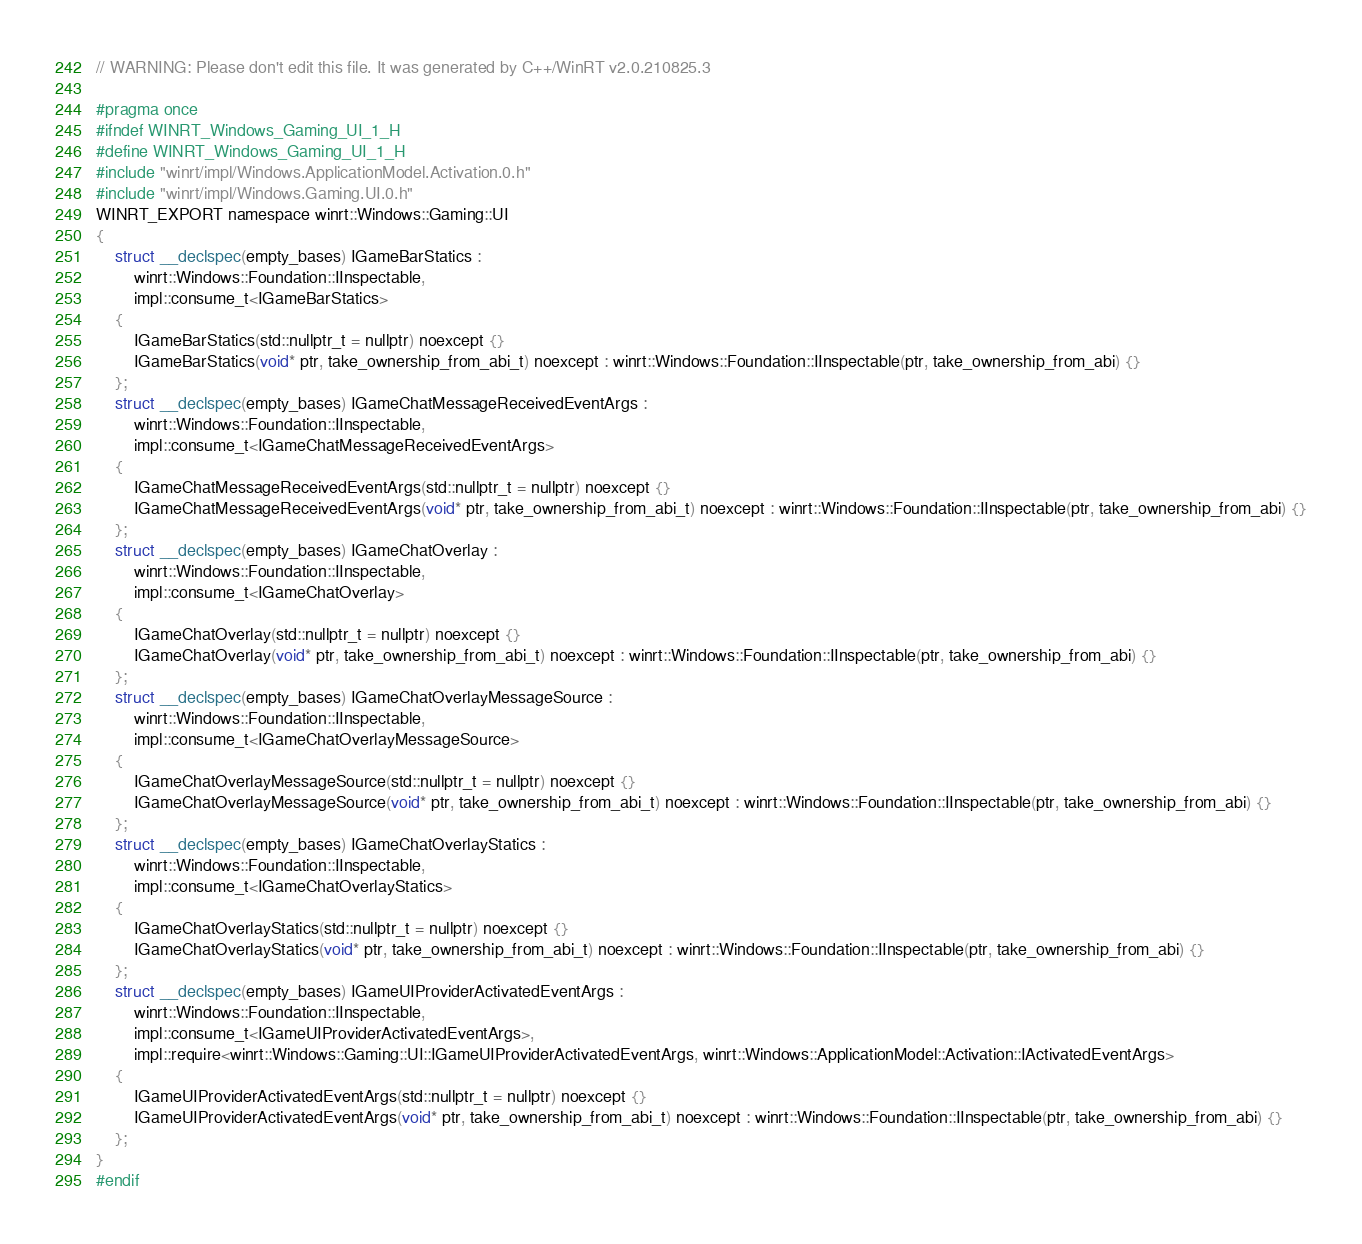Convert code to text. <code><loc_0><loc_0><loc_500><loc_500><_C_>// WARNING: Please don't edit this file. It was generated by C++/WinRT v2.0.210825.3

#pragma once
#ifndef WINRT_Windows_Gaming_UI_1_H
#define WINRT_Windows_Gaming_UI_1_H
#include "winrt/impl/Windows.ApplicationModel.Activation.0.h"
#include "winrt/impl/Windows.Gaming.UI.0.h"
WINRT_EXPORT namespace winrt::Windows::Gaming::UI
{
    struct __declspec(empty_bases) IGameBarStatics :
        winrt::Windows::Foundation::IInspectable,
        impl::consume_t<IGameBarStatics>
    {
        IGameBarStatics(std::nullptr_t = nullptr) noexcept {}
        IGameBarStatics(void* ptr, take_ownership_from_abi_t) noexcept : winrt::Windows::Foundation::IInspectable(ptr, take_ownership_from_abi) {}
    };
    struct __declspec(empty_bases) IGameChatMessageReceivedEventArgs :
        winrt::Windows::Foundation::IInspectable,
        impl::consume_t<IGameChatMessageReceivedEventArgs>
    {
        IGameChatMessageReceivedEventArgs(std::nullptr_t = nullptr) noexcept {}
        IGameChatMessageReceivedEventArgs(void* ptr, take_ownership_from_abi_t) noexcept : winrt::Windows::Foundation::IInspectable(ptr, take_ownership_from_abi) {}
    };
    struct __declspec(empty_bases) IGameChatOverlay :
        winrt::Windows::Foundation::IInspectable,
        impl::consume_t<IGameChatOverlay>
    {
        IGameChatOverlay(std::nullptr_t = nullptr) noexcept {}
        IGameChatOverlay(void* ptr, take_ownership_from_abi_t) noexcept : winrt::Windows::Foundation::IInspectable(ptr, take_ownership_from_abi) {}
    };
    struct __declspec(empty_bases) IGameChatOverlayMessageSource :
        winrt::Windows::Foundation::IInspectable,
        impl::consume_t<IGameChatOverlayMessageSource>
    {
        IGameChatOverlayMessageSource(std::nullptr_t = nullptr) noexcept {}
        IGameChatOverlayMessageSource(void* ptr, take_ownership_from_abi_t) noexcept : winrt::Windows::Foundation::IInspectable(ptr, take_ownership_from_abi) {}
    };
    struct __declspec(empty_bases) IGameChatOverlayStatics :
        winrt::Windows::Foundation::IInspectable,
        impl::consume_t<IGameChatOverlayStatics>
    {
        IGameChatOverlayStatics(std::nullptr_t = nullptr) noexcept {}
        IGameChatOverlayStatics(void* ptr, take_ownership_from_abi_t) noexcept : winrt::Windows::Foundation::IInspectable(ptr, take_ownership_from_abi) {}
    };
    struct __declspec(empty_bases) IGameUIProviderActivatedEventArgs :
        winrt::Windows::Foundation::IInspectable,
        impl::consume_t<IGameUIProviderActivatedEventArgs>,
        impl::require<winrt::Windows::Gaming::UI::IGameUIProviderActivatedEventArgs, winrt::Windows::ApplicationModel::Activation::IActivatedEventArgs>
    {
        IGameUIProviderActivatedEventArgs(std::nullptr_t = nullptr) noexcept {}
        IGameUIProviderActivatedEventArgs(void* ptr, take_ownership_from_abi_t) noexcept : winrt::Windows::Foundation::IInspectable(ptr, take_ownership_from_abi) {}
    };
}
#endif
</code> 